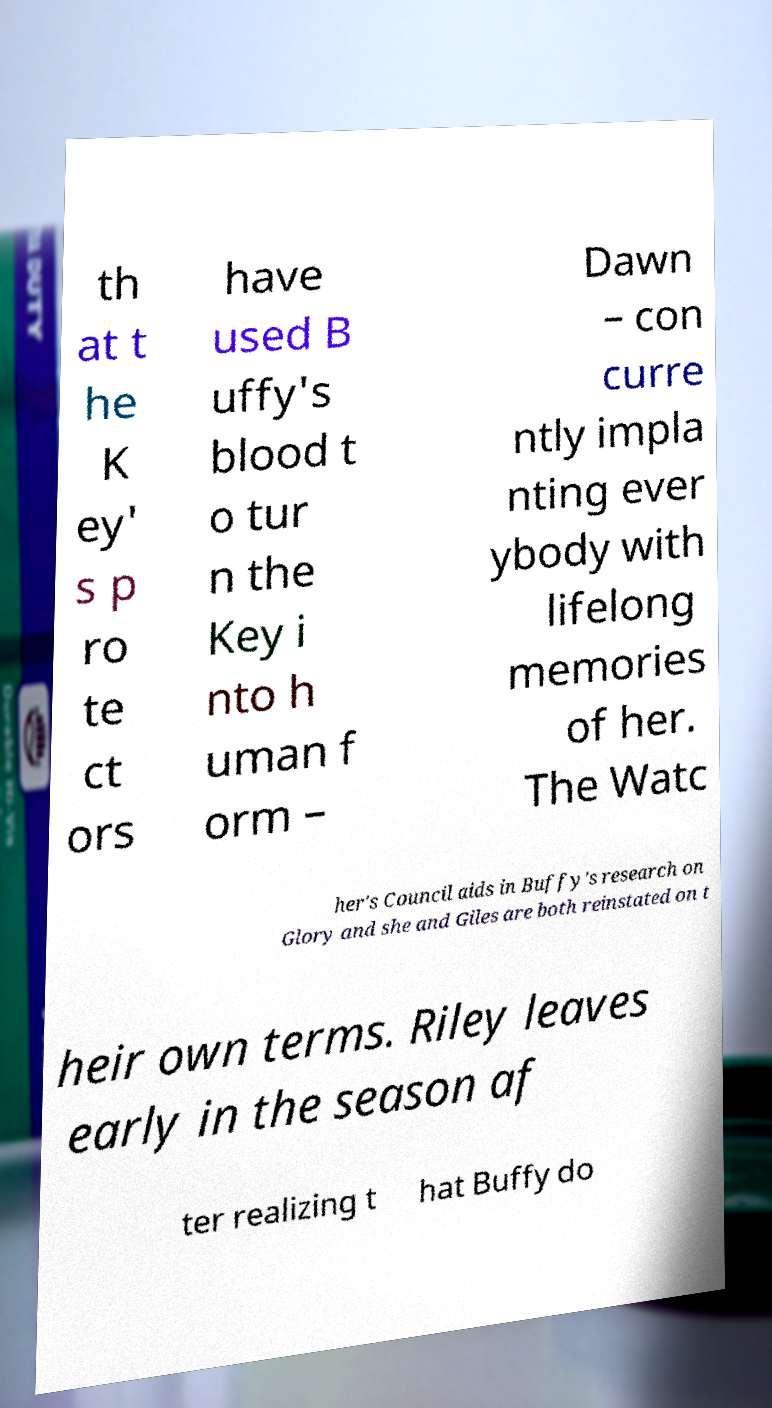Please identify and transcribe the text found in this image. th at t he K ey' s p ro te ct ors have used B uffy's blood t o tur n the Key i nto h uman f orm – Dawn – con curre ntly impla nting ever ybody with lifelong memories of her. The Watc her's Council aids in Buffy's research on Glory and she and Giles are both reinstated on t heir own terms. Riley leaves early in the season af ter realizing t hat Buffy do 